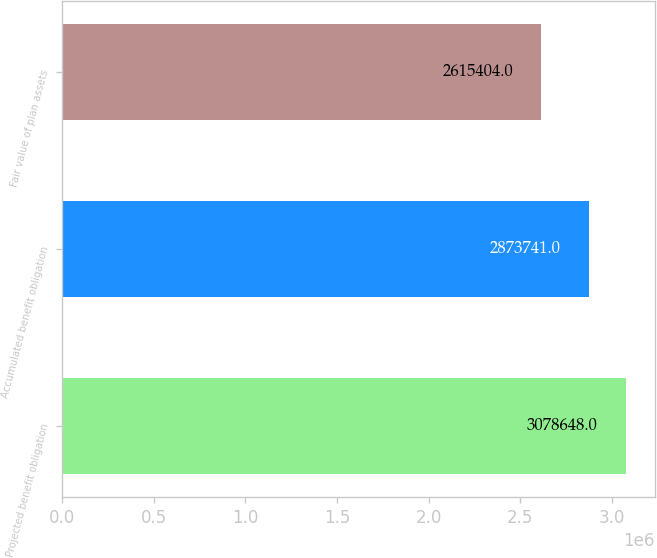Convert chart to OTSL. <chart><loc_0><loc_0><loc_500><loc_500><bar_chart><fcel>Projected benefit obligation<fcel>Accumulated benefit obligation<fcel>Fair value of plan assets<nl><fcel>3.07865e+06<fcel>2.87374e+06<fcel>2.6154e+06<nl></chart> 